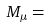<formula> <loc_0><loc_0><loc_500><loc_500>M _ { \mu } =</formula> 